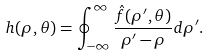<formula> <loc_0><loc_0><loc_500><loc_500>h ( \rho , \theta ) = \oint _ { - \infty } ^ { \infty } \frac { \hat { f } ( \rho ^ { \prime } , \theta ) } { \rho ^ { \prime } - \rho } d \rho ^ { \prime } .</formula> 